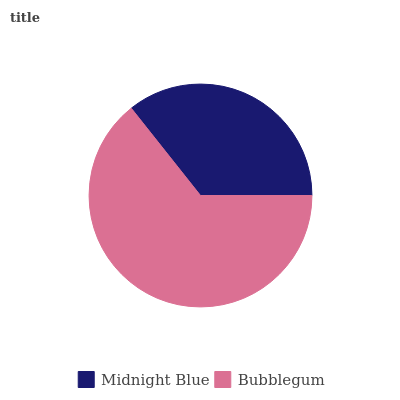Is Midnight Blue the minimum?
Answer yes or no. Yes. Is Bubblegum the maximum?
Answer yes or no. Yes. Is Bubblegum the minimum?
Answer yes or no. No. Is Bubblegum greater than Midnight Blue?
Answer yes or no. Yes. Is Midnight Blue less than Bubblegum?
Answer yes or no. Yes. Is Midnight Blue greater than Bubblegum?
Answer yes or no. No. Is Bubblegum less than Midnight Blue?
Answer yes or no. No. Is Bubblegum the high median?
Answer yes or no. Yes. Is Midnight Blue the low median?
Answer yes or no. Yes. Is Midnight Blue the high median?
Answer yes or no. No. Is Bubblegum the low median?
Answer yes or no. No. 